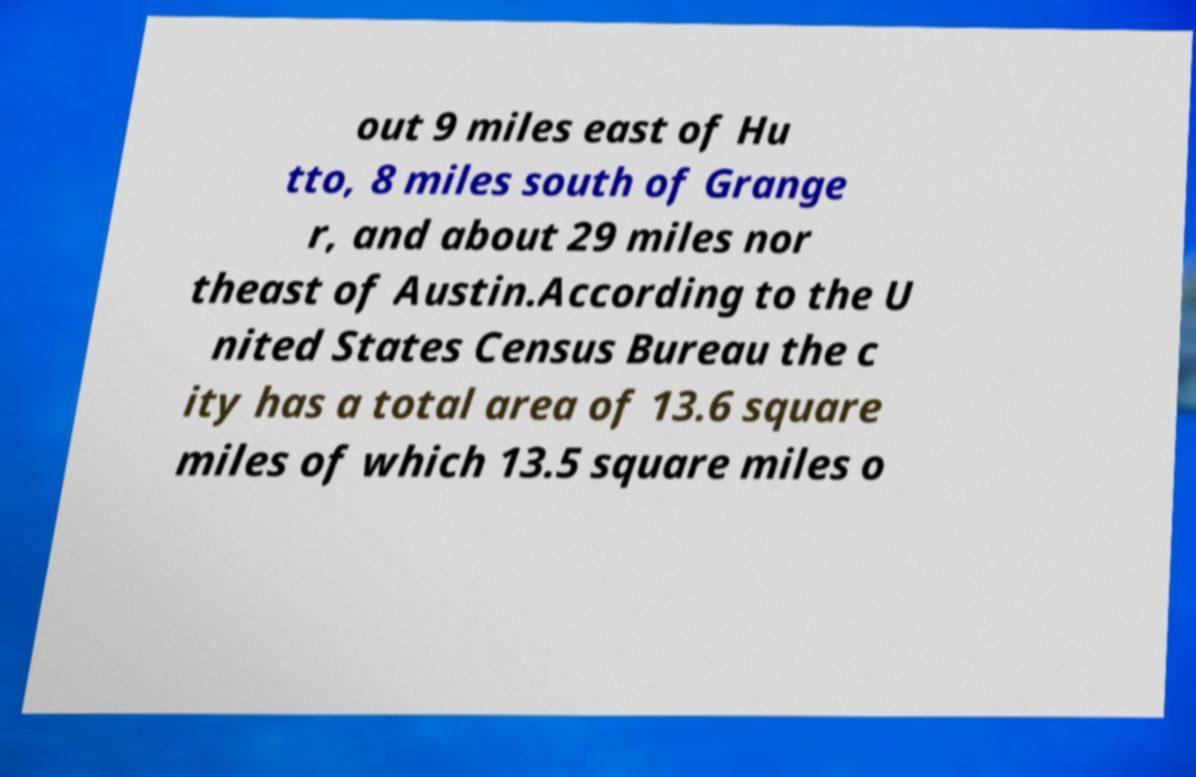For documentation purposes, I need the text within this image transcribed. Could you provide that? out 9 miles east of Hu tto, 8 miles south of Grange r, and about 29 miles nor theast of Austin.According to the U nited States Census Bureau the c ity has a total area of 13.6 square miles of which 13.5 square miles o 